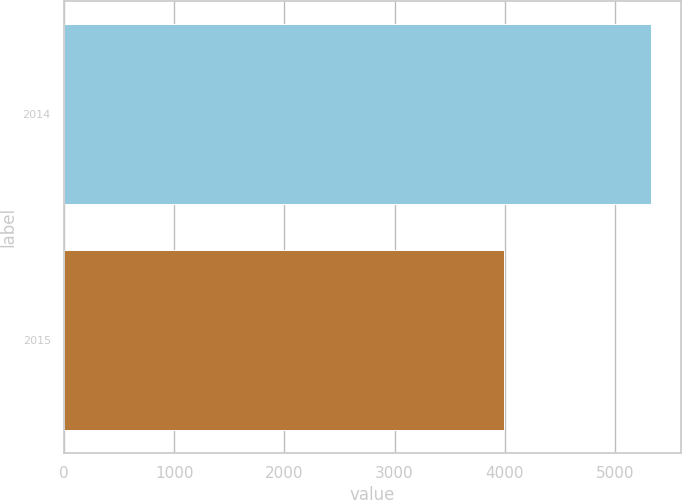Convert chart to OTSL. <chart><loc_0><loc_0><loc_500><loc_500><bar_chart><fcel>2014<fcel>2015<nl><fcel>5330<fcel>3997<nl></chart> 